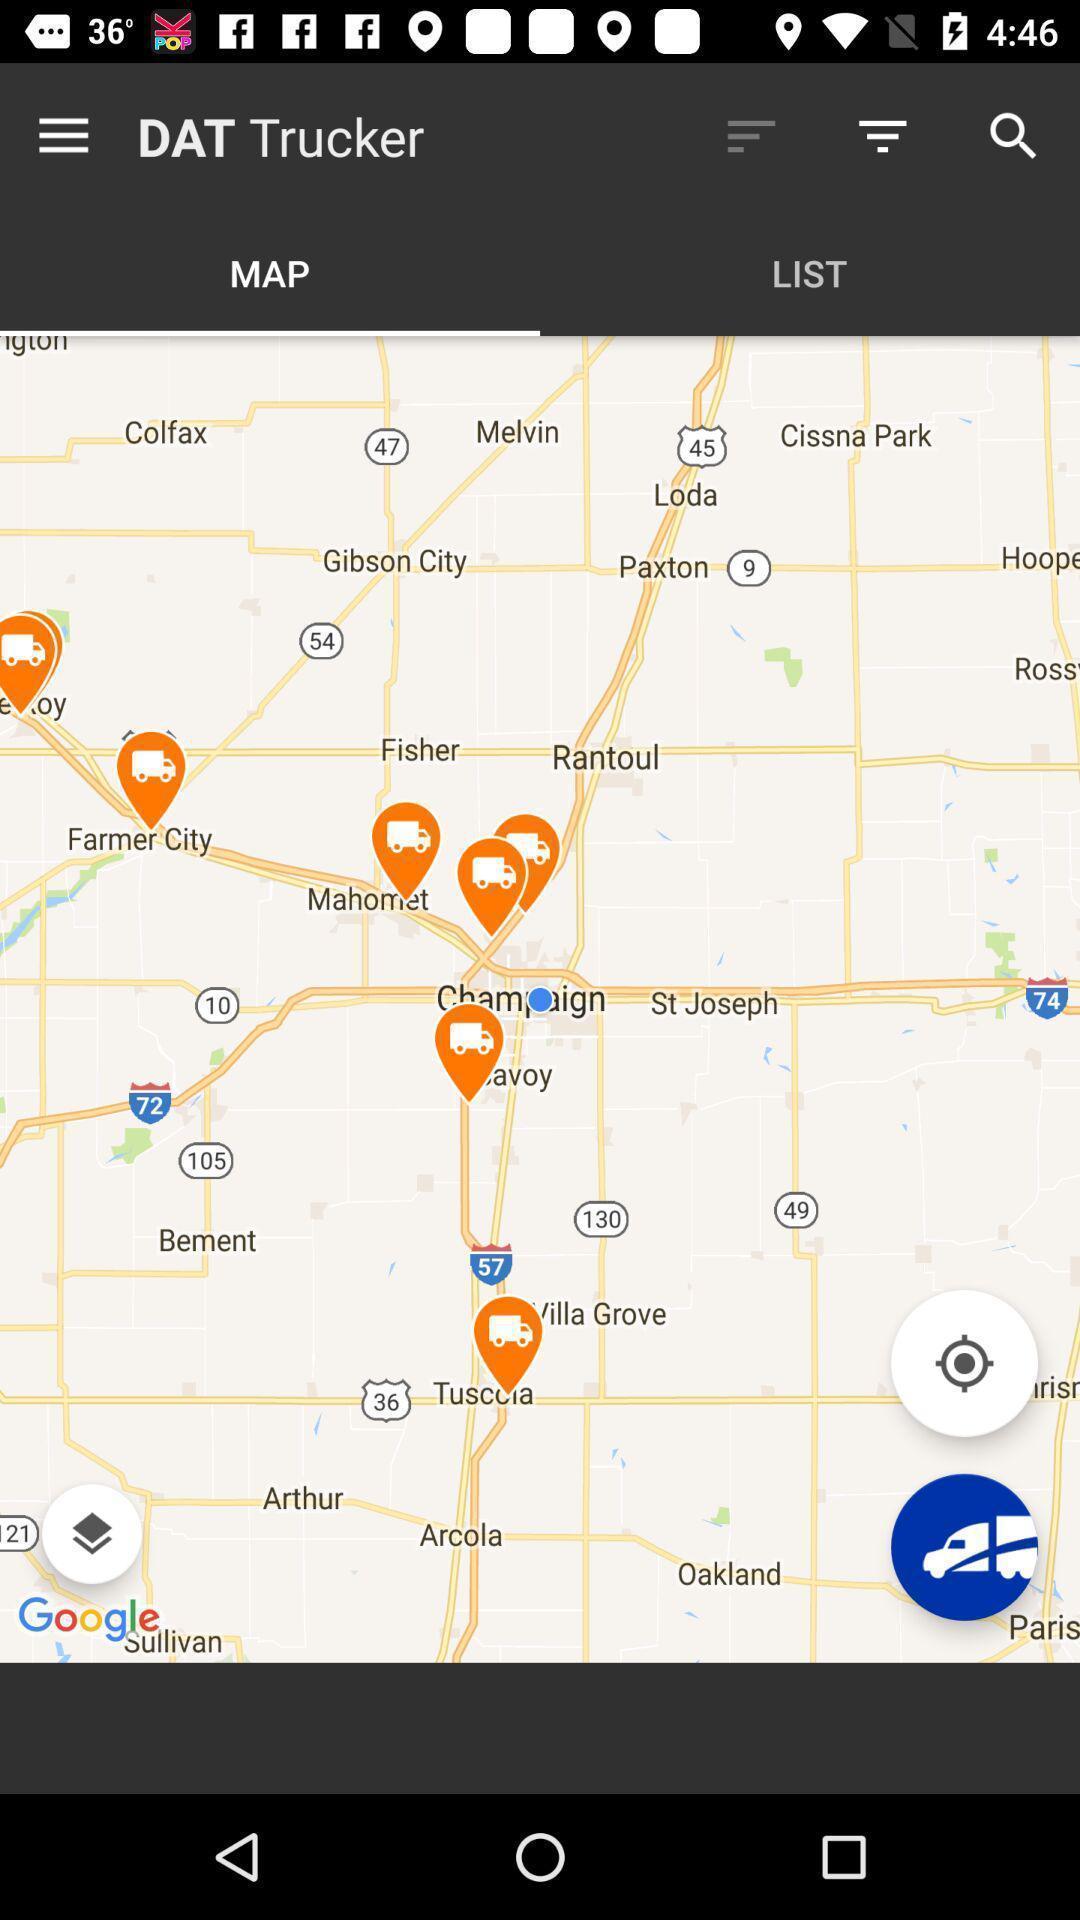What is the overall content of this screenshot? Page showing map of a region. 